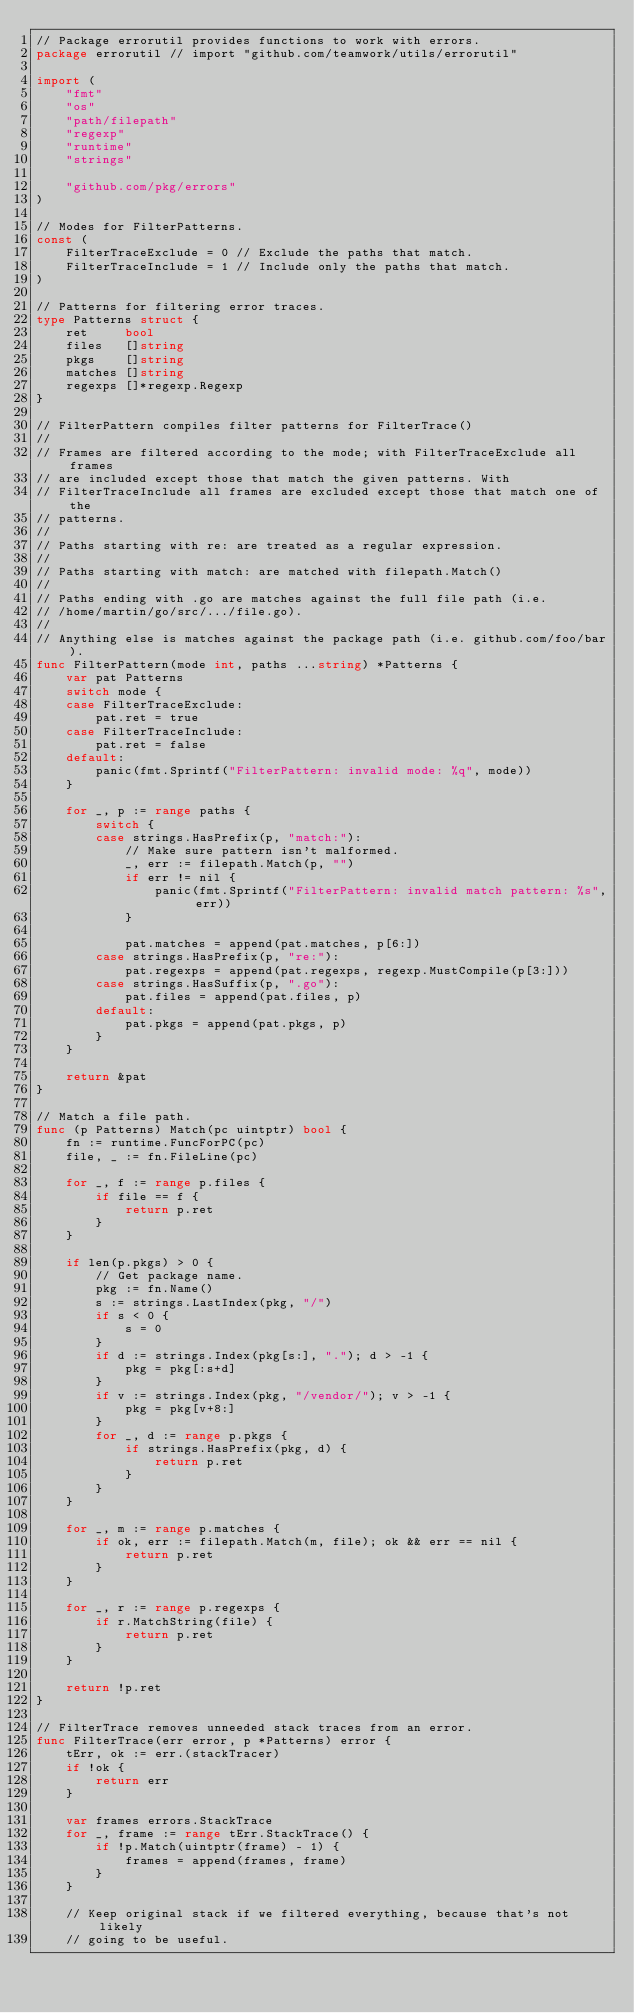Convert code to text. <code><loc_0><loc_0><loc_500><loc_500><_Go_>// Package errorutil provides functions to work with errors.
package errorutil // import "github.com/teamwork/utils/errorutil"

import (
	"fmt"
	"os"
	"path/filepath"
	"regexp"
	"runtime"
	"strings"

	"github.com/pkg/errors"
)

// Modes for FilterPatterns.
const (
	FilterTraceExclude = 0 // Exclude the paths that match.
	FilterTraceInclude = 1 // Include only the paths that match.
)

// Patterns for filtering error traces.
type Patterns struct {
	ret     bool
	files   []string
	pkgs    []string
	matches []string
	regexps []*regexp.Regexp
}

// FilterPattern compiles filter patterns for FilterTrace()
//
// Frames are filtered according to the mode; with FilterTraceExclude all frames
// are included except those that match the given patterns. With
// FilterTraceInclude all frames are excluded except those that match one of the
// patterns.
//
// Paths starting with re: are treated as a regular expression.
//
// Paths starting with match: are matched with filepath.Match()
//
// Paths ending with .go are matches against the full file path (i.e.
// /home/martin/go/src/.../file.go).
//
// Anything else is matches against the package path (i.e. github.com/foo/bar).
func FilterPattern(mode int, paths ...string) *Patterns {
	var pat Patterns
	switch mode {
	case FilterTraceExclude:
		pat.ret = true
	case FilterTraceInclude:
		pat.ret = false
	default:
		panic(fmt.Sprintf("FilterPattern: invalid mode: %q", mode))
	}

	for _, p := range paths {
		switch {
		case strings.HasPrefix(p, "match:"):
			// Make sure pattern isn't malformed.
			_, err := filepath.Match(p, "")
			if err != nil {
				panic(fmt.Sprintf("FilterPattern: invalid match pattern: %s", err))
			}

			pat.matches = append(pat.matches, p[6:])
		case strings.HasPrefix(p, "re:"):
			pat.regexps = append(pat.regexps, regexp.MustCompile(p[3:]))
		case strings.HasSuffix(p, ".go"):
			pat.files = append(pat.files, p)
		default:
			pat.pkgs = append(pat.pkgs, p)
		}
	}

	return &pat
}

// Match a file path.
func (p Patterns) Match(pc uintptr) bool {
	fn := runtime.FuncForPC(pc)
	file, _ := fn.FileLine(pc)

	for _, f := range p.files {
		if file == f {
			return p.ret
		}
	}

	if len(p.pkgs) > 0 {
		// Get package name.
		pkg := fn.Name()
		s := strings.LastIndex(pkg, "/")
		if s < 0 {
			s = 0
		}
		if d := strings.Index(pkg[s:], "."); d > -1 {
			pkg = pkg[:s+d]
		}
		if v := strings.Index(pkg, "/vendor/"); v > -1 {
			pkg = pkg[v+8:]
		}
		for _, d := range p.pkgs {
			if strings.HasPrefix(pkg, d) {
				return p.ret
			}
		}
	}

	for _, m := range p.matches {
		if ok, err := filepath.Match(m, file); ok && err == nil {
			return p.ret
		}
	}

	for _, r := range p.regexps {
		if r.MatchString(file) {
			return p.ret
		}
	}

	return !p.ret
}

// FilterTrace removes unneeded stack traces from an error.
func FilterTrace(err error, p *Patterns) error {
	tErr, ok := err.(stackTracer)
	if !ok {
		return err
	}

	var frames errors.StackTrace
	for _, frame := range tErr.StackTrace() {
		if !p.Match(uintptr(frame) - 1) {
			frames = append(frames, frame)
		}
	}

	// Keep original stack if we filtered everything, because that's not likely
	// going to be useful.</code> 